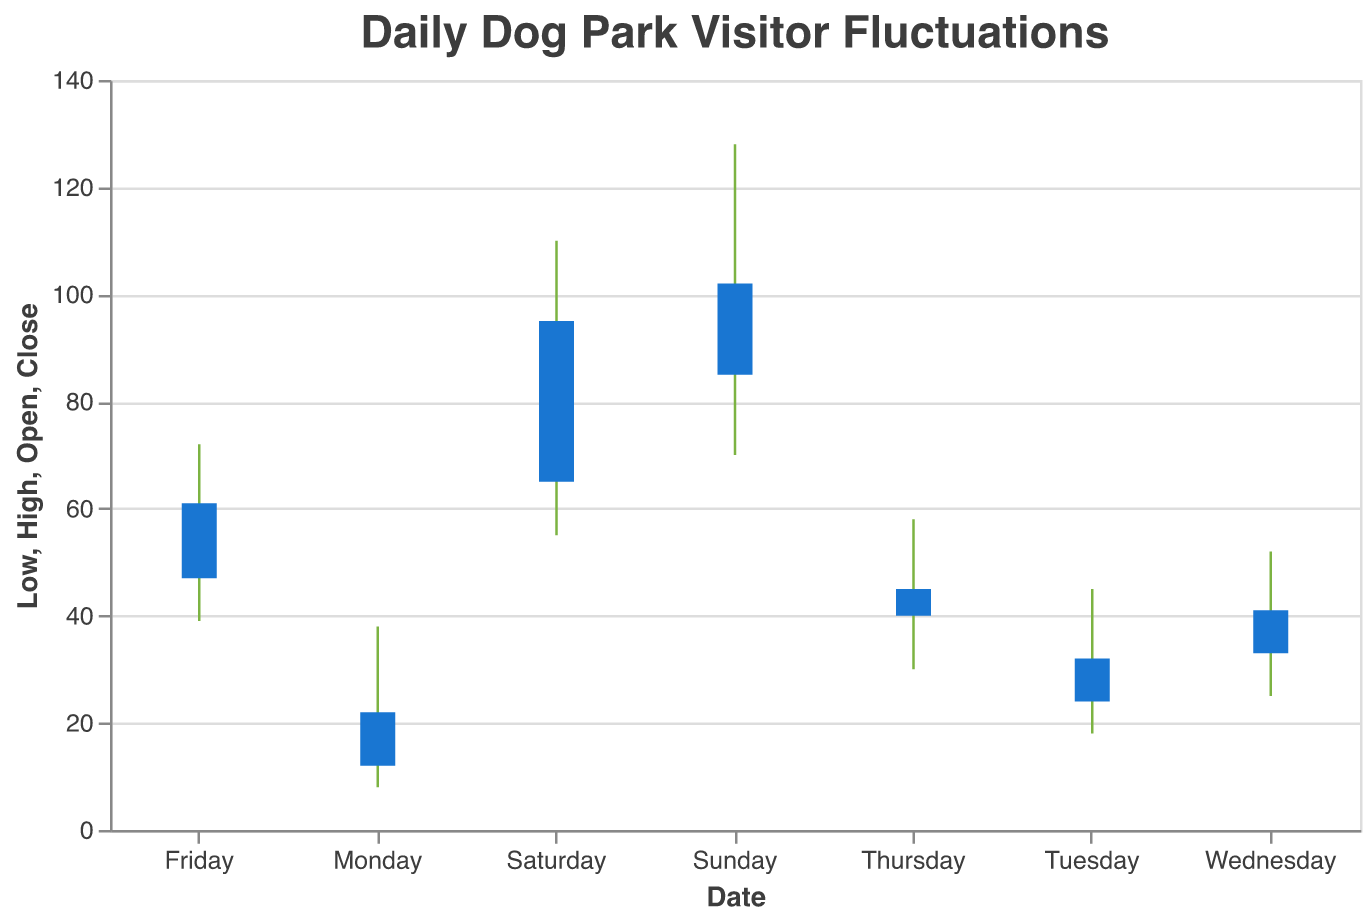What is the title of the chart? The title of the chart is prominently displayed at the top of the figure.
Answer: Daily Dog Park Visitor Fluctuations What are the names of the days plotted on the x-axis? The x-axis lists the names of the days as labels for each data point. The days listed are Monday, Tuesday, Wednesday, Thursday, Friday, Saturday, and Sunday.
Answer: Monday, Tuesday, Wednesday, Thursday, Friday, Saturday, Sunday What is the color of the bars representing the daily data? The color of the bars can be identified visually in the chart, where they are displayed prominently with a distinct color.
Answer: Blue What is the highest visitor count recorded in a day? To find the highest visitor count, look at the peak 'High' values of each day. The highest value among Monday to Sunday is 128 on Sunday.
Answer: 128 How many visitors were at the dog park on Monday at both the lowest and highest points? Locate Monday on the x-axis and find the corresponding 'Low' and 'High' values. The lowest count is 8 and the highest count is 38.
Answer: 8 (Low) and 38 (High) On which day was the difference between the highest and the lowest number of visitors the greatest? Calculate the range (High - Low) for each day and compare them. Monday is 30, Tuesday is 27, Wednesday is 27, Thursday is 28, Friday is 33, Saturday is 55, Sunday is 58. Sunday has the greatest difference.
Answer: Sunday What is the sum of the 'Close' values for the entire week? Add up the 'Close' values for each day: 22 (Monday) + 32 (Tuesday) + 41 (Wednesday) + 45 (Thursday) + 61 (Friday) + 95 (Saturday) + 102 (Sunday) = 398.
Answer: 398 Which day had a higher closing visitor count, Thursday or Friday? Compare the 'Close' values for Thursday and Friday. Thursday's Close is 45, while Friday's Close is 61. Friday had a higher closing count.
Answer: Friday What is the average 'Open' value for the week? To find the average 'Open' value, sum the 'Open' values and divide by the number of days: (12 + 24 + 33 + 40 + 47 + 65 + 85) / 7 = 43.71.
Answer: 43.71 Is there a trend in the number of visitors over the week? Analyze the 'Open' values or 'Close' values over the days to see if they generally increase or decrease. The values show a clear increase from Monday to Sunday, indicating an increasing trend.
Answer: Increasing trend 